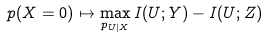<formula> <loc_0><loc_0><loc_500><loc_500>p ( X = 0 ) \mapsto \max _ { p _ { U | X } } I ( U ; Y ) - I ( U ; Z )</formula> 